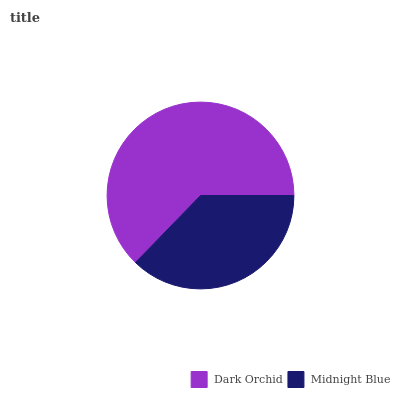Is Midnight Blue the minimum?
Answer yes or no. Yes. Is Dark Orchid the maximum?
Answer yes or no. Yes. Is Midnight Blue the maximum?
Answer yes or no. No. Is Dark Orchid greater than Midnight Blue?
Answer yes or no. Yes. Is Midnight Blue less than Dark Orchid?
Answer yes or no. Yes. Is Midnight Blue greater than Dark Orchid?
Answer yes or no. No. Is Dark Orchid less than Midnight Blue?
Answer yes or no. No. Is Dark Orchid the high median?
Answer yes or no. Yes. Is Midnight Blue the low median?
Answer yes or no. Yes. Is Midnight Blue the high median?
Answer yes or no. No. Is Dark Orchid the low median?
Answer yes or no. No. 